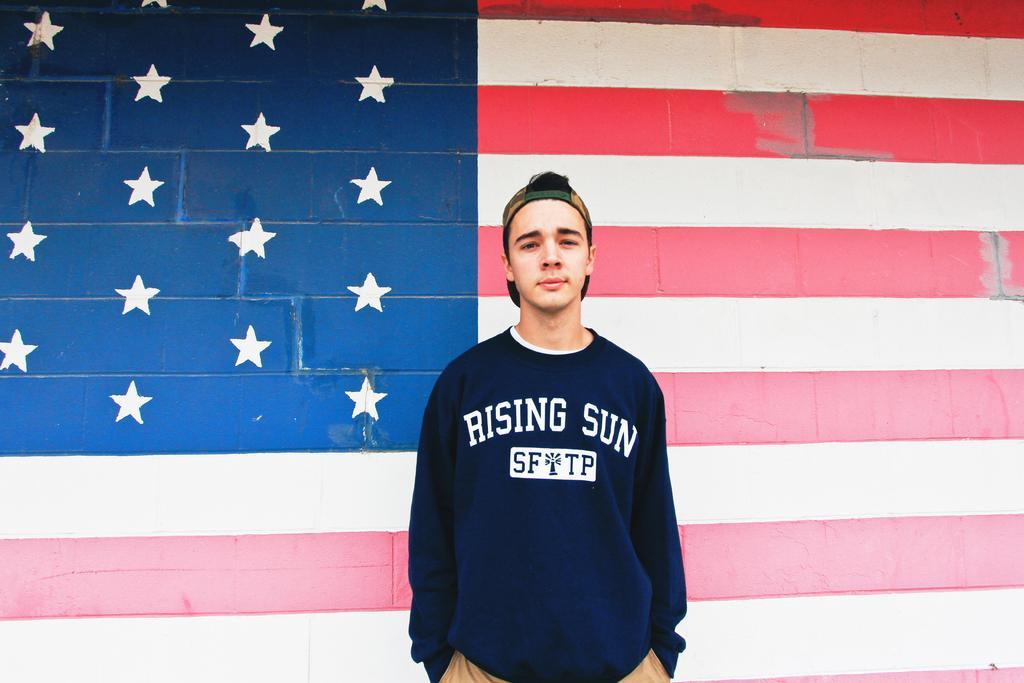How would you summarize this image in a sentence or two? In this picture we can see a man with a cap. Behind the man, there is the painting of a flag on the wall. 